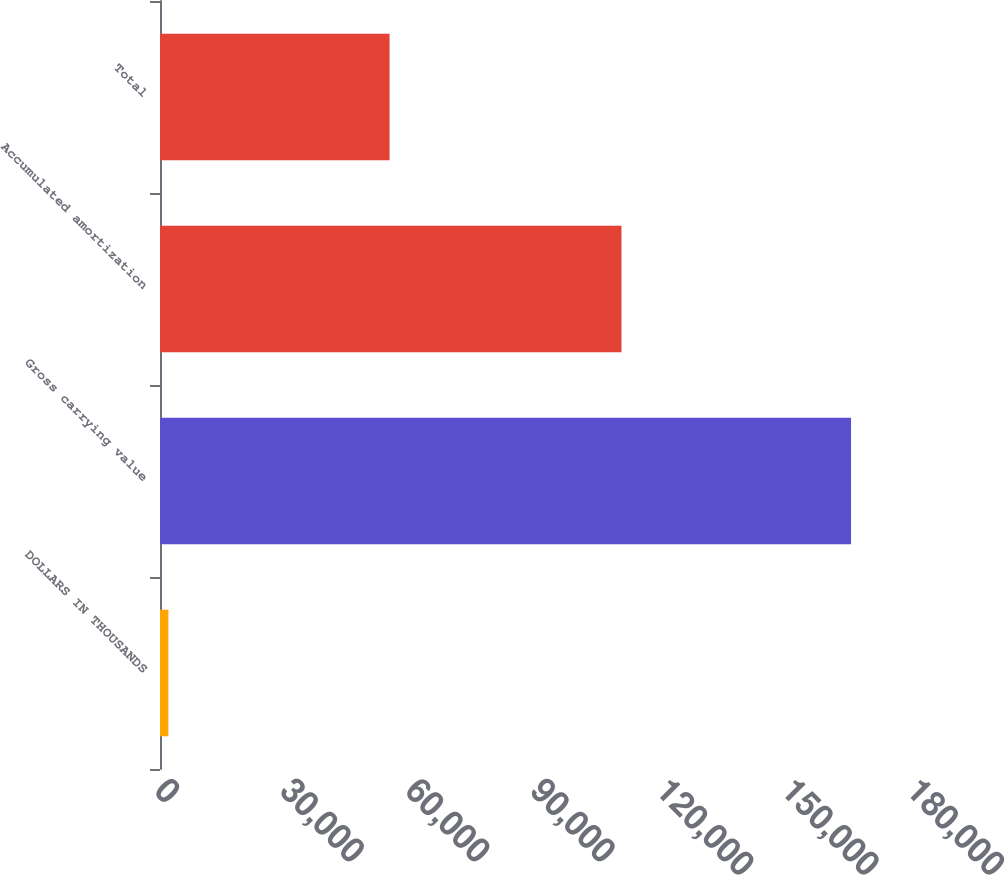<chart> <loc_0><loc_0><loc_500><loc_500><bar_chart><fcel>DOLLARS IN THOUSANDS<fcel>Gross carrying value<fcel>Accumulated amortization<fcel>Total<nl><fcel>2009<fcel>165406<fcel>110458<fcel>54948<nl></chart> 